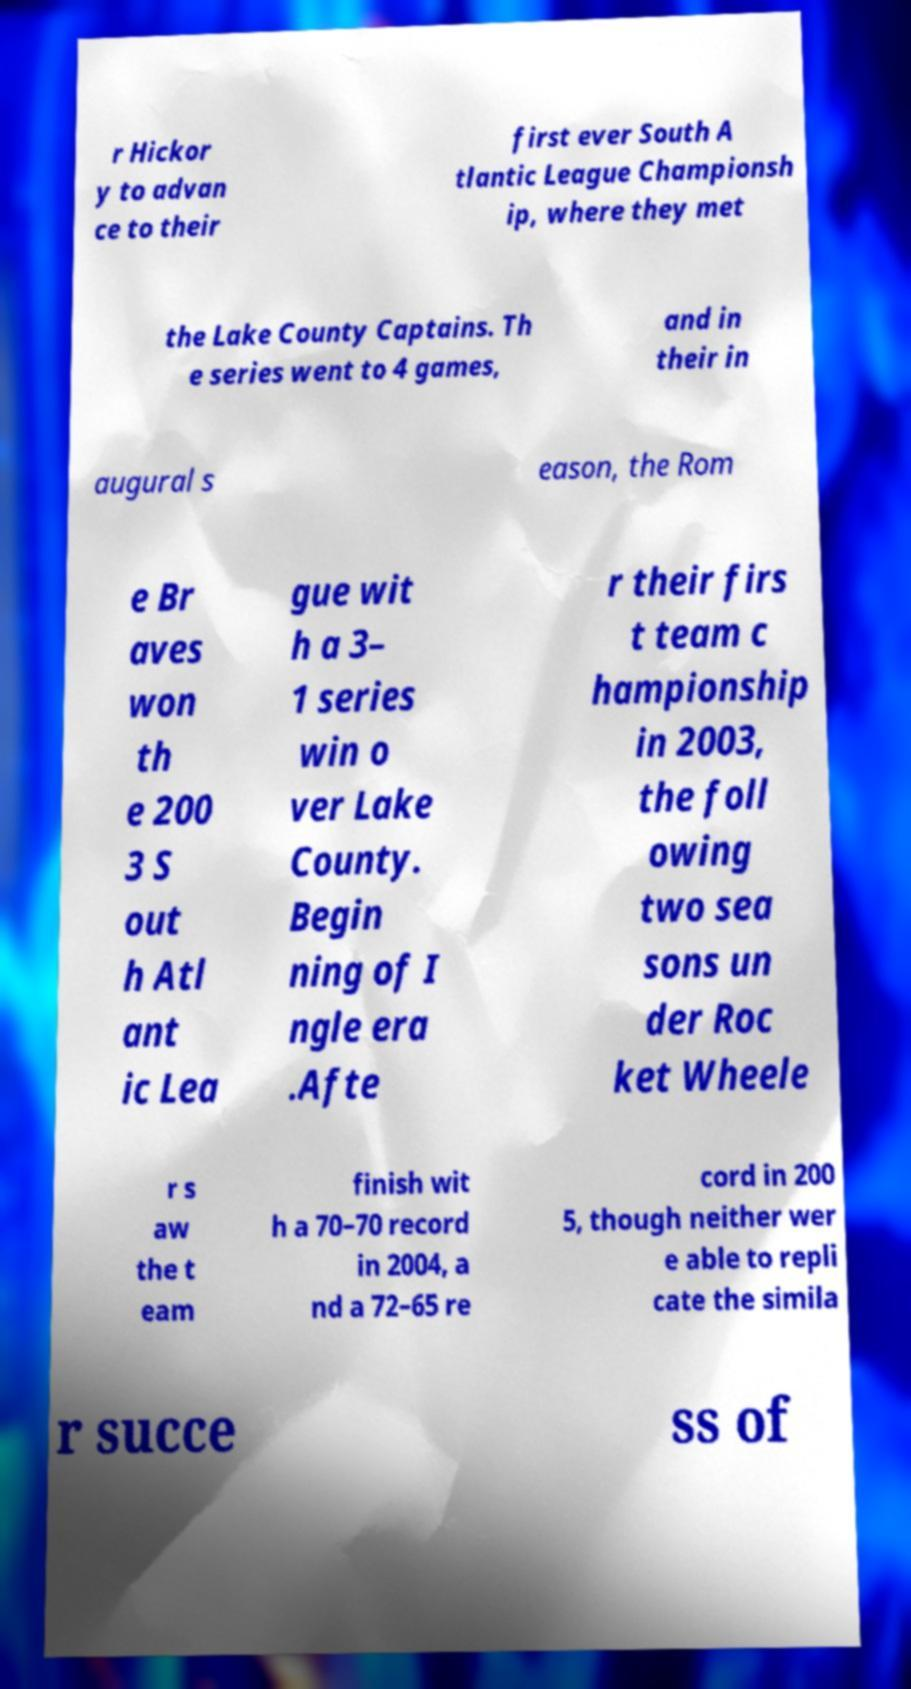What messages or text are displayed in this image? I need them in a readable, typed format. r Hickor y to advan ce to their first ever South A tlantic League Championsh ip, where they met the Lake County Captains. Th e series went to 4 games, and in their in augural s eason, the Rom e Br aves won th e 200 3 S out h Atl ant ic Lea gue wit h a 3– 1 series win o ver Lake County. Begin ning of I ngle era .Afte r their firs t team c hampionship in 2003, the foll owing two sea sons un der Roc ket Wheele r s aw the t eam finish wit h a 70–70 record in 2004, a nd a 72–65 re cord in 200 5, though neither wer e able to repli cate the simila r succe ss of 